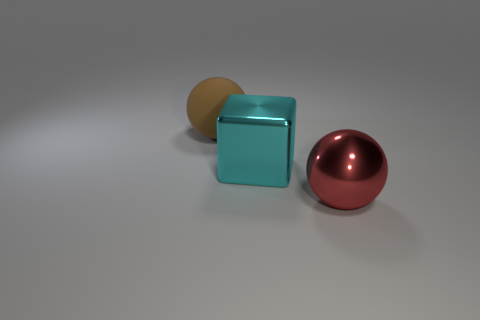Add 2 big shiny balls. How many objects exist? 5 Subtract 1 spheres. How many spheres are left? 1 Subtract all blocks. How many objects are left? 2 Subtract all green balls. Subtract all red cylinders. How many balls are left? 2 Subtract all gray cubes. How many red spheres are left? 1 Add 2 red spheres. How many red spheres are left? 3 Add 2 blue blocks. How many blue blocks exist? 2 Subtract 1 cyan blocks. How many objects are left? 2 Subtract all blue shiny blocks. Subtract all red balls. How many objects are left? 2 